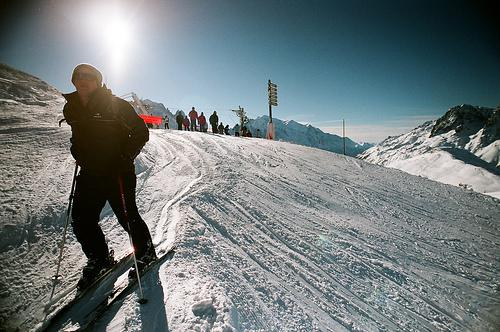Question: what is on the ground?
Choices:
A. Ice.
B. Leaves.
C. Rain.
D. Snow.
Answer with the letter. Answer: D Question: how many people are on skis?
Choices:
A. Zero.
B. One.
C. Three.
D. Six.
Answer with the letter. Answer: B Question: what do the man on the ski have on his face?
Choices:
A. Ski mask.
B. Nose plugs.
C. Dark shades.
D. Hat with eye and nose holes.
Answer with the letter. Answer: C Question: what color is the sky?
Choices:
A. Blue.
B. Red.
C. Pink.
D. Black.
Answer with the letter. Answer: A Question: where was the picture taken?
Choices:
A. At the beach.
B. At the arena.
C. At a ski resort.
D. At the fair grounds.
Answer with the letter. Answer: C 